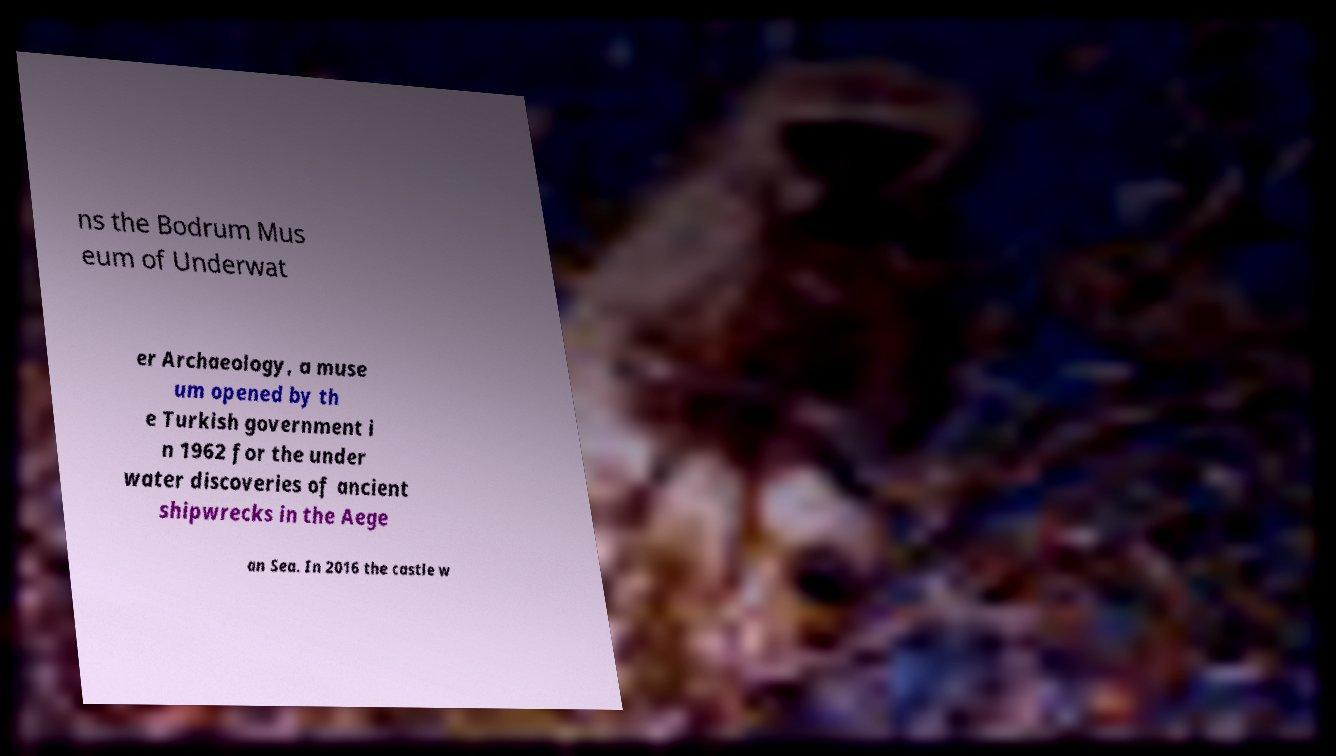What messages or text are displayed in this image? I need them in a readable, typed format. ns the Bodrum Mus eum of Underwat er Archaeology, a muse um opened by th e Turkish government i n 1962 for the under water discoveries of ancient shipwrecks in the Aege an Sea. In 2016 the castle w 